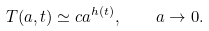<formula> <loc_0><loc_0><loc_500><loc_500>T ( a , t ) \simeq c a ^ { h ( t ) } , \quad a \rightarrow 0 .</formula> 